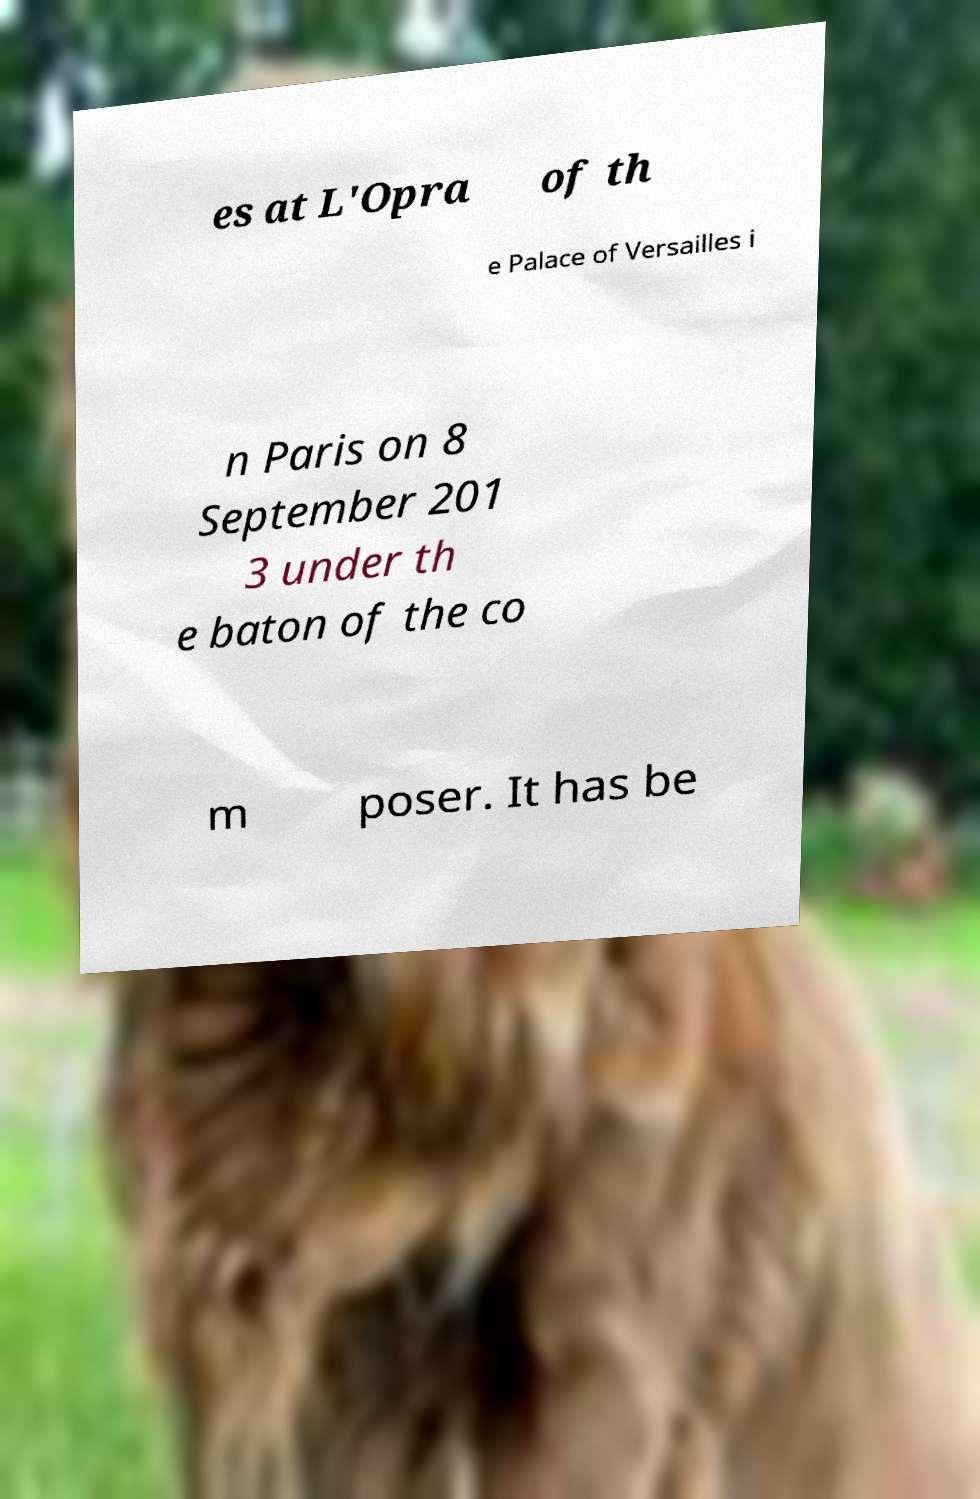Could you assist in decoding the text presented in this image and type it out clearly? es at L'Opra of th e Palace of Versailles i n Paris on 8 September 201 3 under th e baton of the co m poser. It has be 